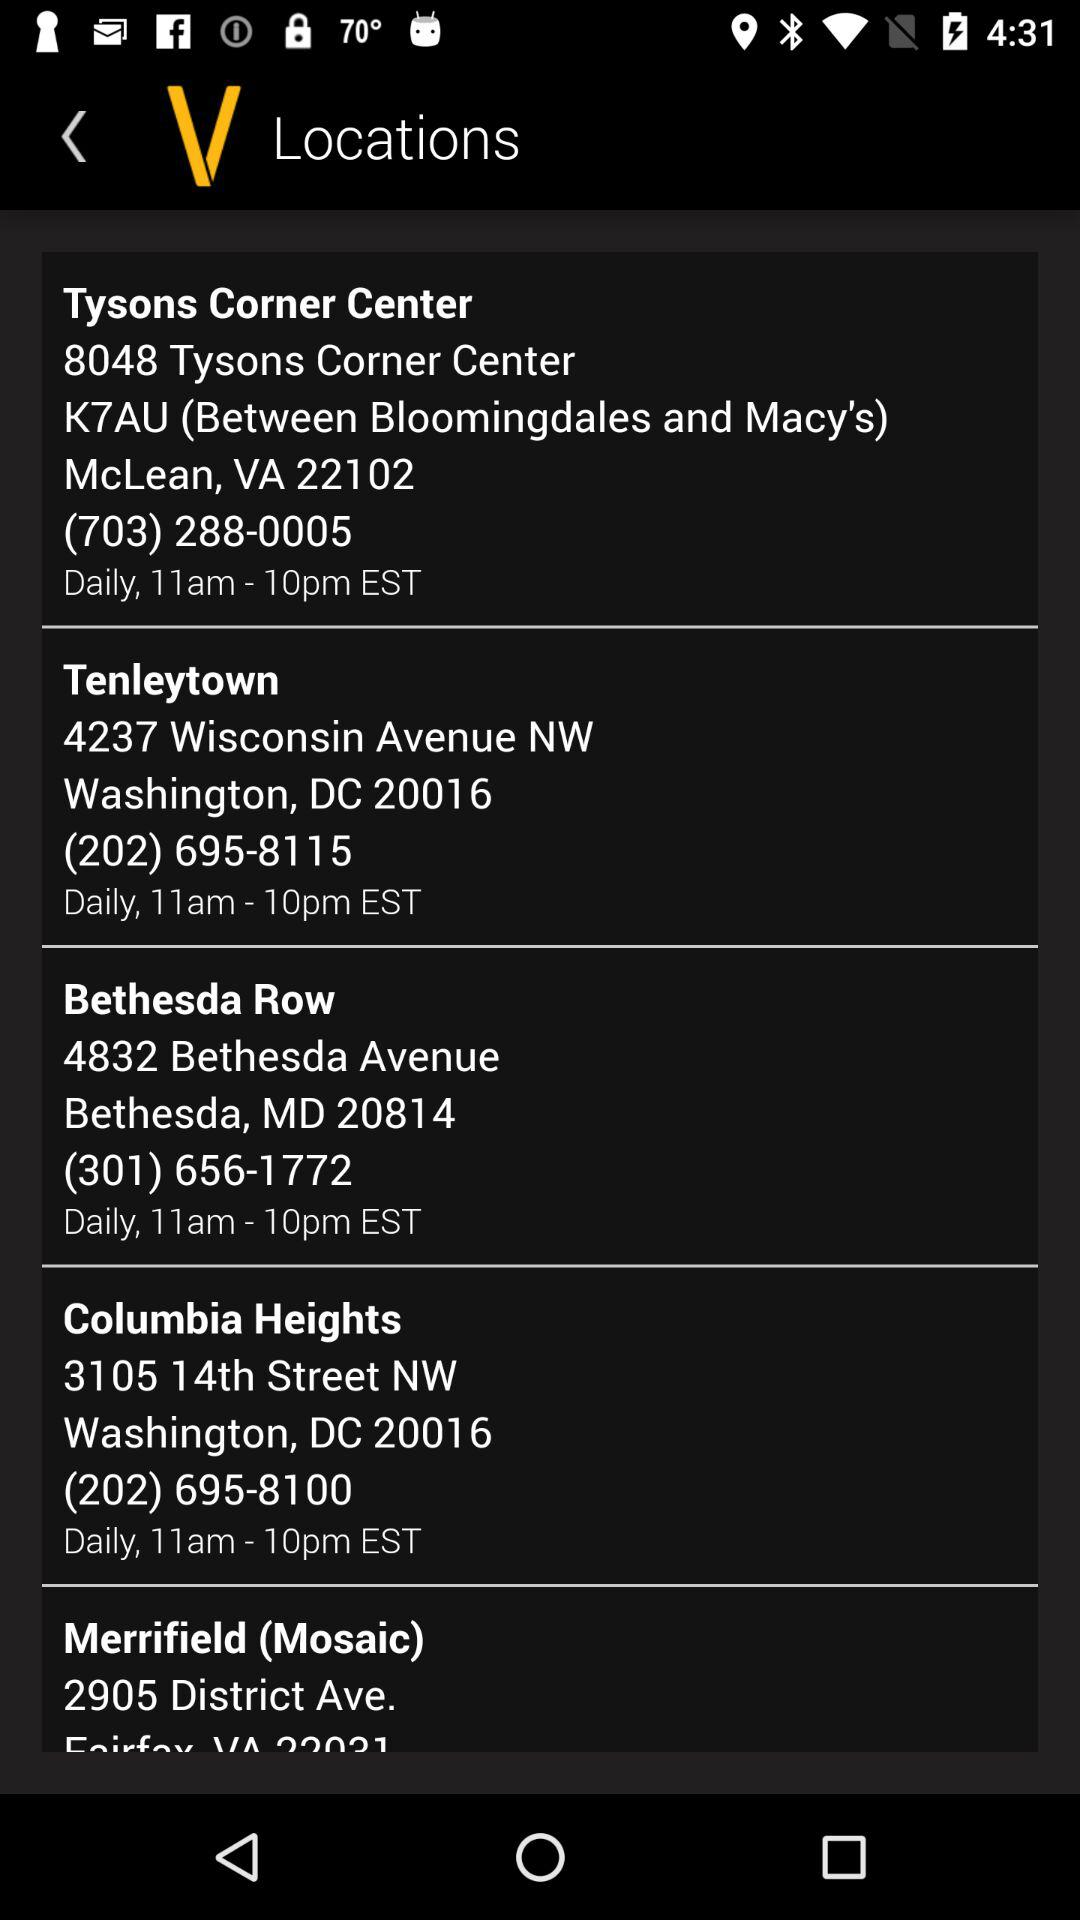What is the phone number for "Bethesda Row"? The phone number is (301) 656-1772. 